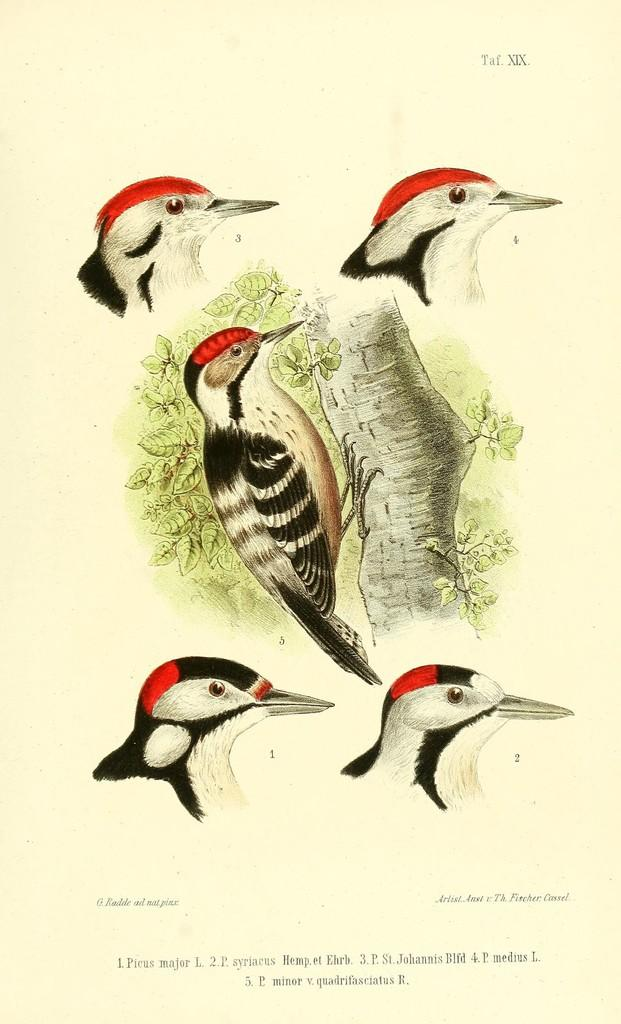What is the main object in the image? There is a paper in the image. What is depicted on the paper? There is a bark of a tree, a bird, and leaves on the paper. What is written or printed at the bottom of the paper? There is text at the bottom of the paper. What else can be seen in the image besides the paper? There are heads of birds visible in the image. What type of rock is visible in the image? There is no rock present in the image. What side of the paper is the bark of the tree printed on? The bark of the tree is not printed on a specific side of the paper, as it is depicted on the paper itself. 